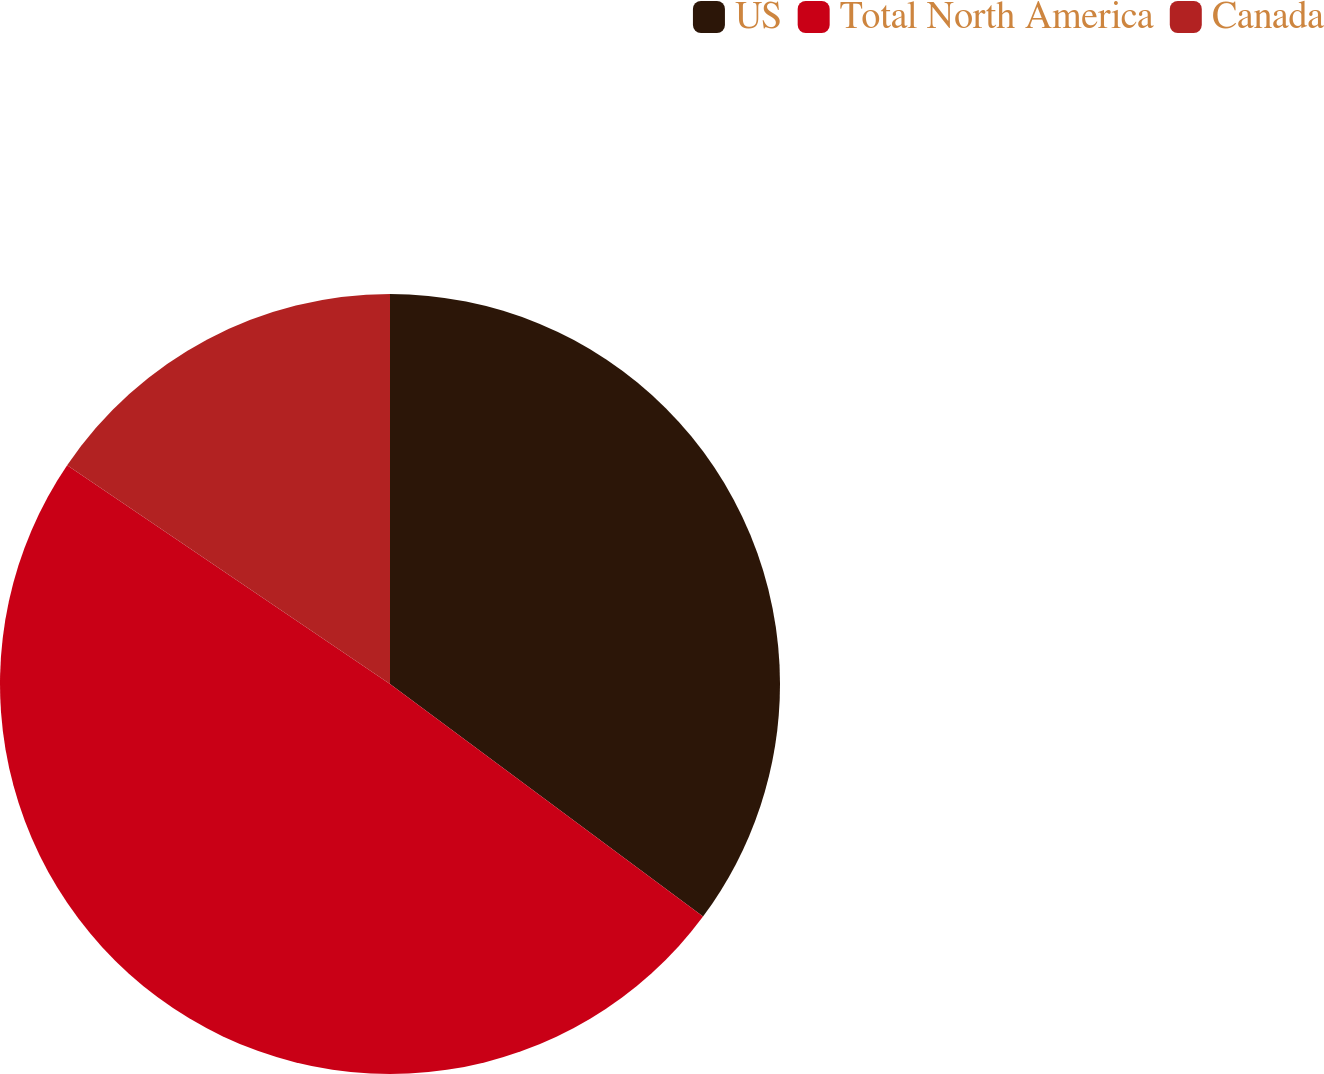Convert chart to OTSL. <chart><loc_0><loc_0><loc_500><loc_500><pie_chart><fcel>US<fcel>Total North America<fcel>Canada<nl><fcel>35.17%<fcel>49.31%<fcel>15.52%<nl></chart> 